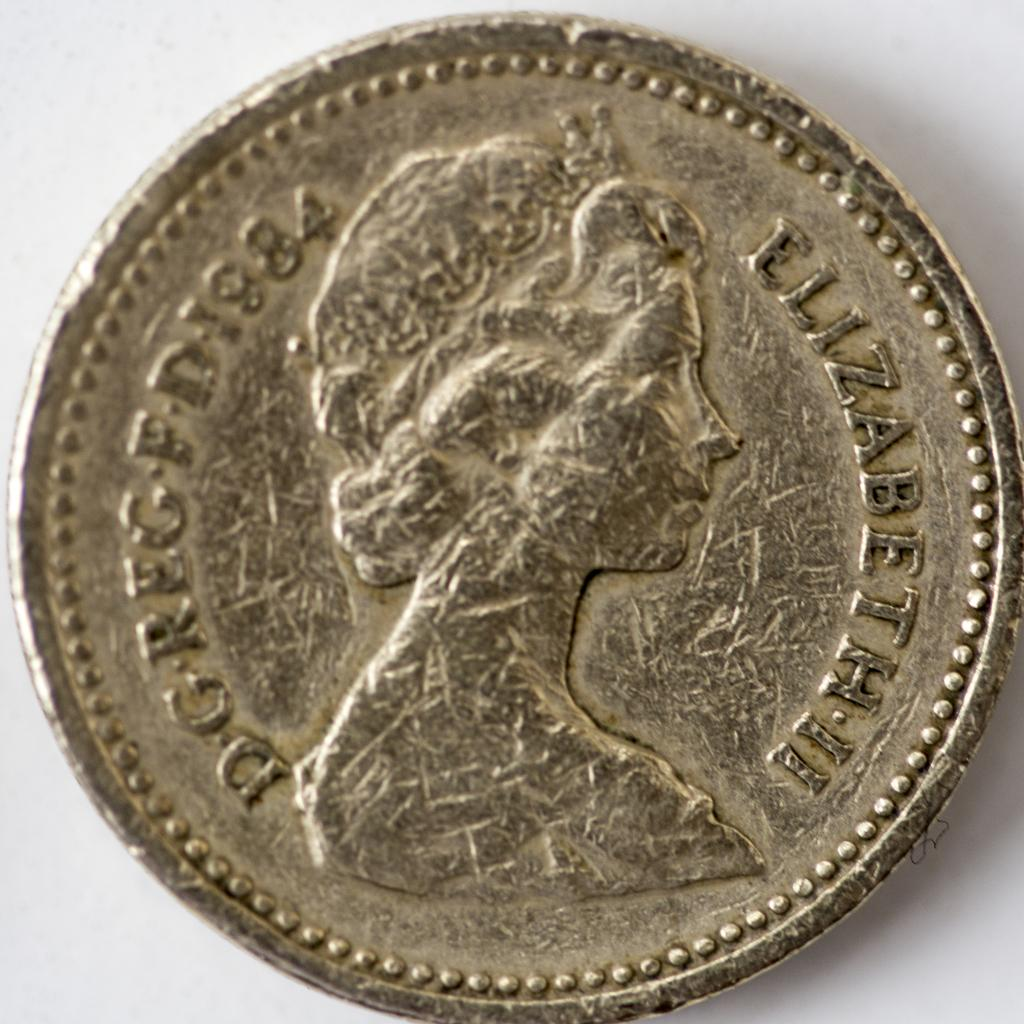<image>
Provide a brief description of the given image. An old 1984 coin featuring Queen Elizabeth II 